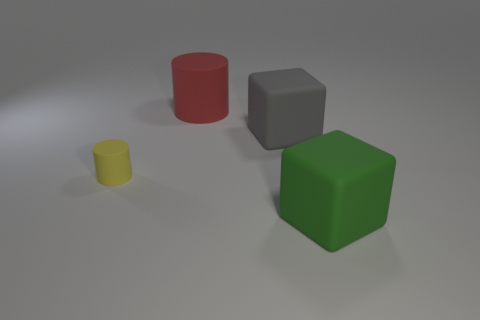Could you describe the significance of the different colors of the blocks? The varied colors yellow, red, green, and grey might be used to categorize or differentiate the blocks, potentially for an educational purpose or simply for aesthetic variety. 